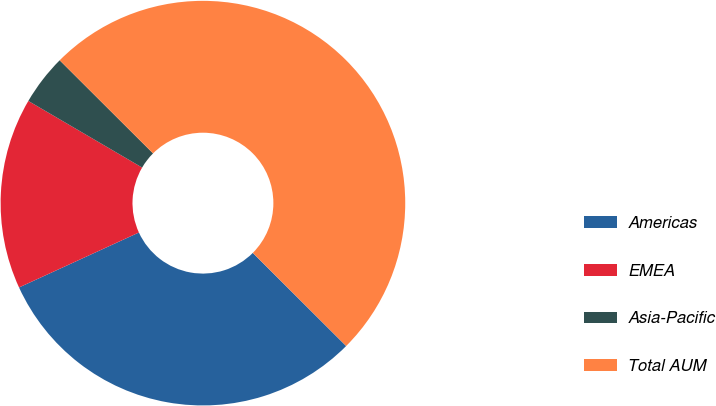Convert chart. <chart><loc_0><loc_0><loc_500><loc_500><pie_chart><fcel>Americas<fcel>EMEA<fcel>Asia-Pacific<fcel>Total AUM<nl><fcel>30.68%<fcel>15.27%<fcel>4.05%<fcel>50.0%<nl></chart> 